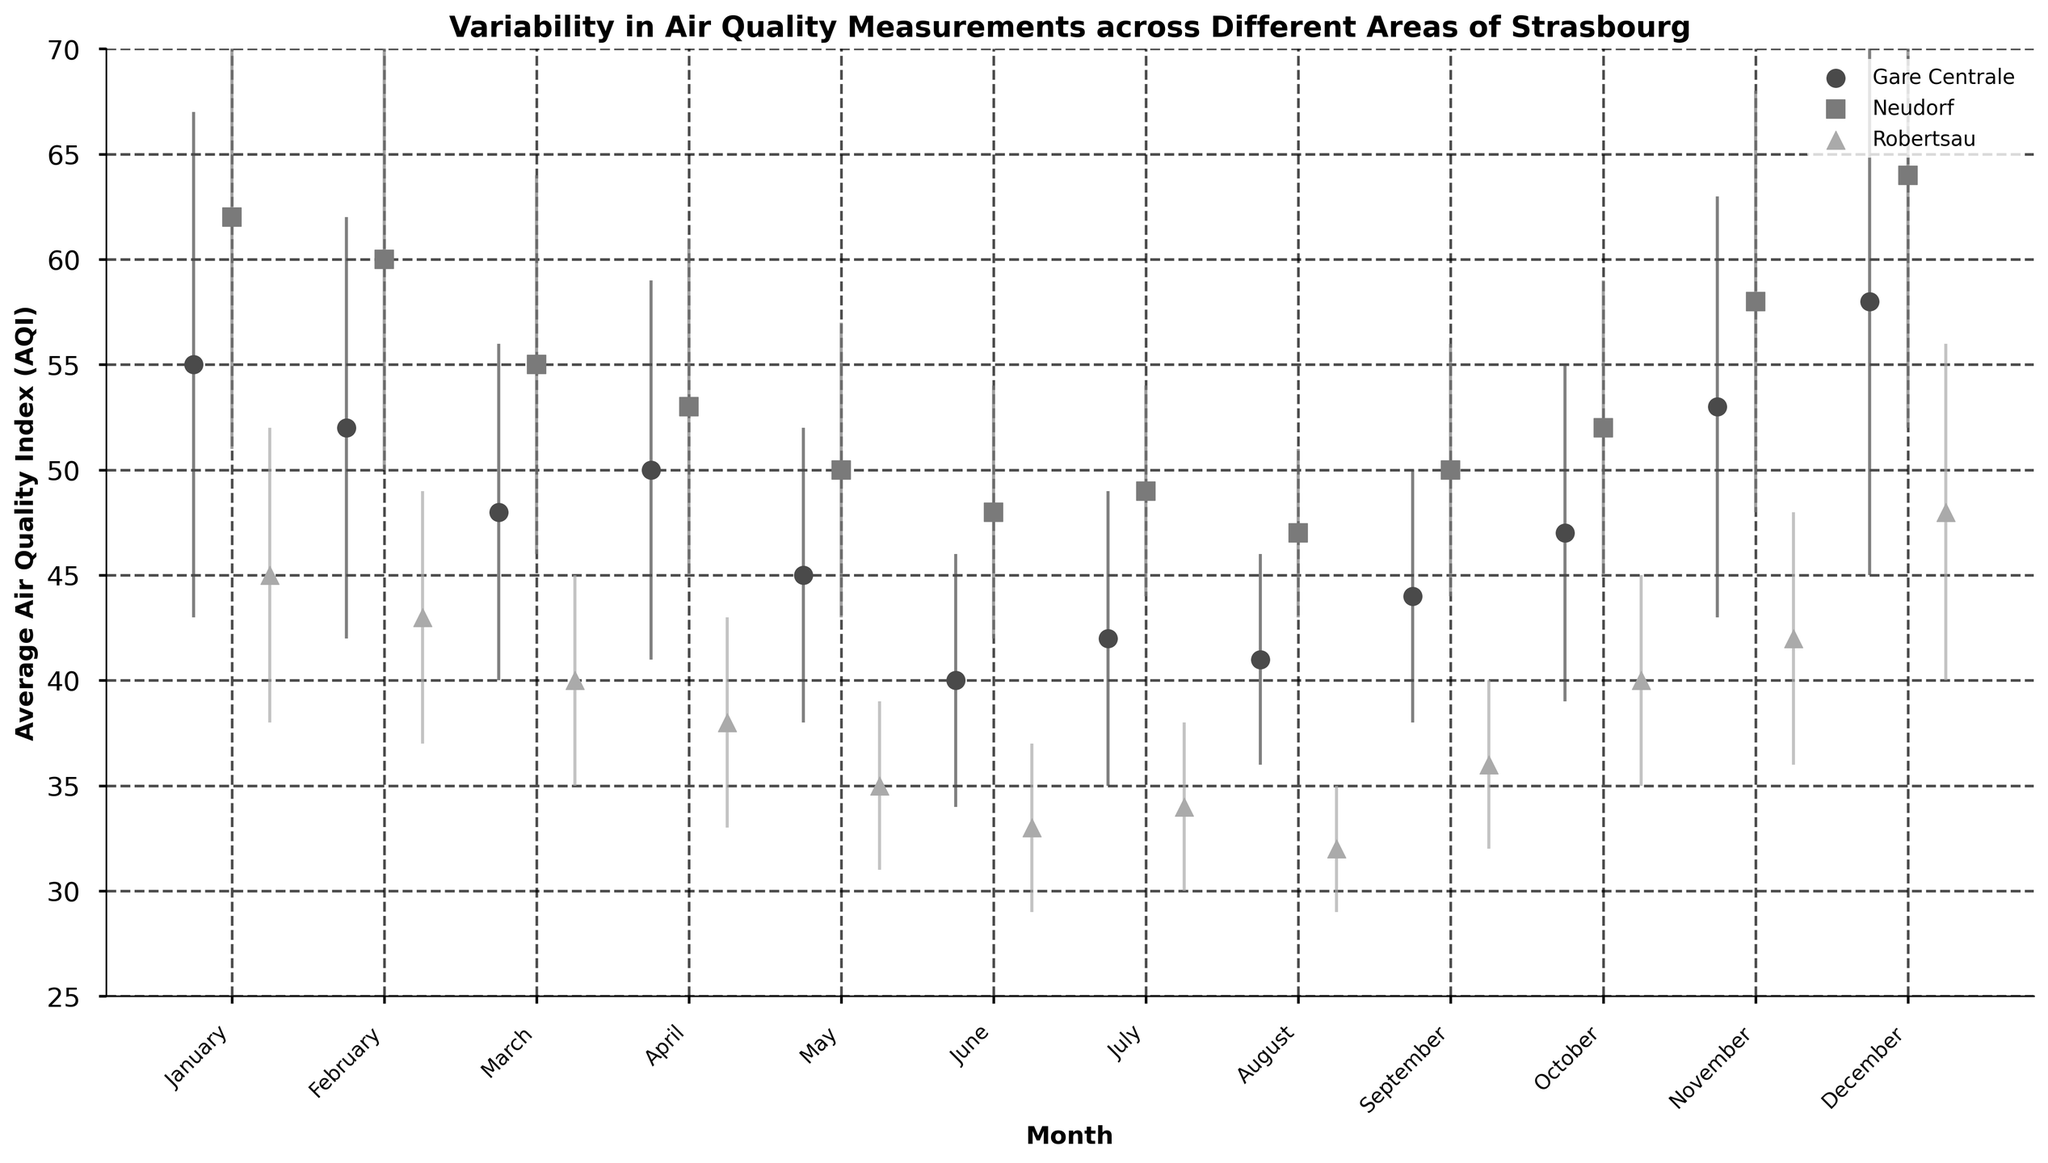Which area has the highest Average AQI in December? From the figure, look for the marker representing each area in December. The highest marker corresponds to the area with the highest AQI.
Answer: Neudorf What is the title of the figure? The title is written at the top of the figure, summarizing the main topic of the plot.
Answer: Variability in Air Quality Measurements across Different Areas of Strasbourg Which month shows the lowest Average AQI in Robertsau? Locate the markers corresponding to Robertsau, typically a specific color/shape, and identify the point that is the lowest.
Answer: August What’s the range of Average AQI in Gare Centrale throughout the year? Identify the highest and lowest AQI values in Gare Centrale from the figure and calculate the difference.
Answer: 58 - 40 = 18 Which area experiences the highest variability in AQI in November? Assess the length of the error bars in November for each area; the longest error bar indicates the highest variability.
Answer: Gare Centrale How does the Average AQI in Neudorf in August compare to June? Look at the positions of the markers for Neudorf in August and June; compare their heights.
Answer: August's Average AQI is lower than June's What is the main visual feature indicating uncertainty in the data? Look at the visual elements in the plot used to represent variability or error.
Answer: Error bars In which months does Gare Centrale have an Average AQI below 45? Identify the markers for Gare Centrale and note the months where the marker is below 45 on the AQI axis.
Answer: May, June, July, August Which month has the widest spread in AQI values across all areas? Compare the spread of error bars for all areas across each month and identify the month with the widest spread.
Answer: December Is there a general trend in AQI values throughout the year for any area? Observe any noticeable upward or downward trends in the markers for any area over the months.
Answer: AQI generally decreases from January to August and increases towards December for all areas 